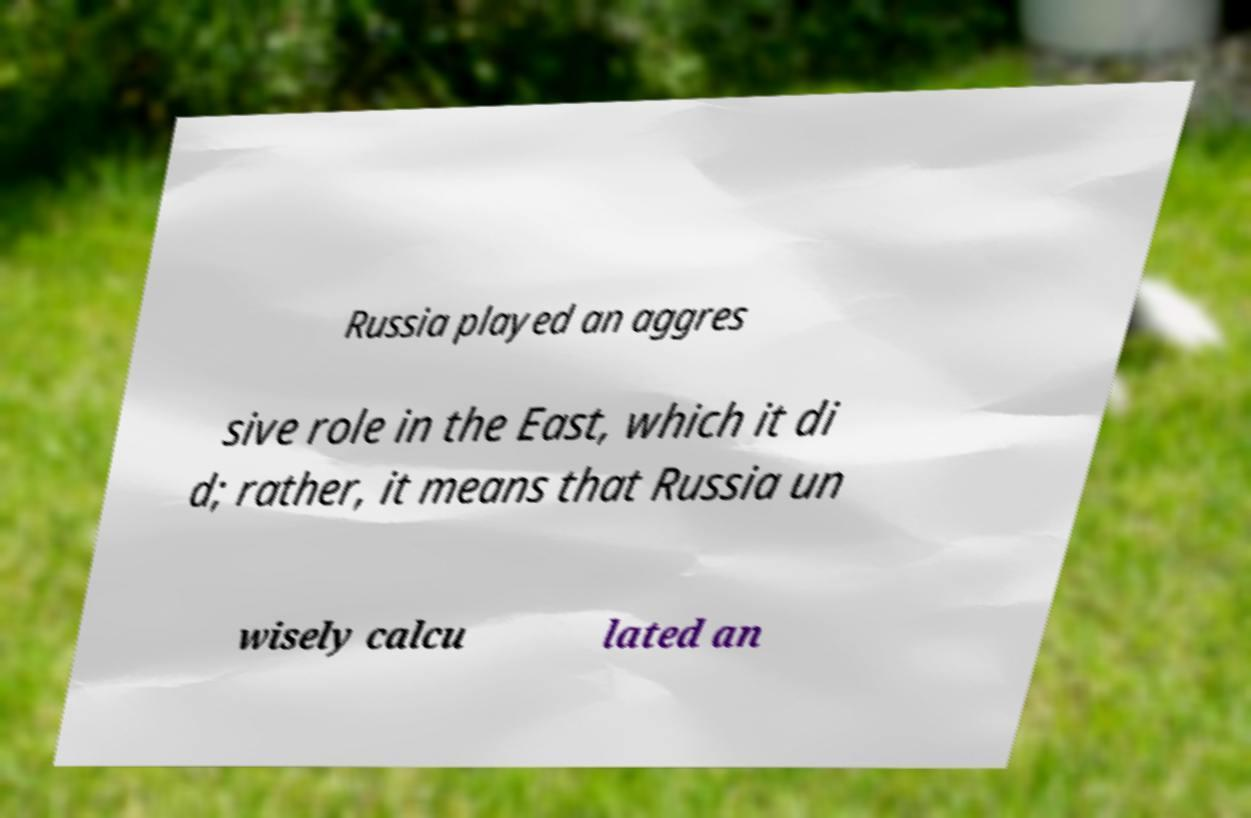Could you extract and type out the text from this image? Russia played an aggres sive role in the East, which it di d; rather, it means that Russia un wisely calcu lated an 